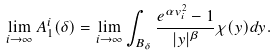Convert formula to latex. <formula><loc_0><loc_0><loc_500><loc_500>\lim _ { i \to \infty } A ^ { i } _ { 1 } ( \delta ) = \lim _ { i \to \infty } \int _ { B _ { \delta } } \frac { e ^ { \alpha v _ { i } ^ { 2 } } - 1 } { | y | ^ { \beta } } \chi ( y ) d y .</formula> 